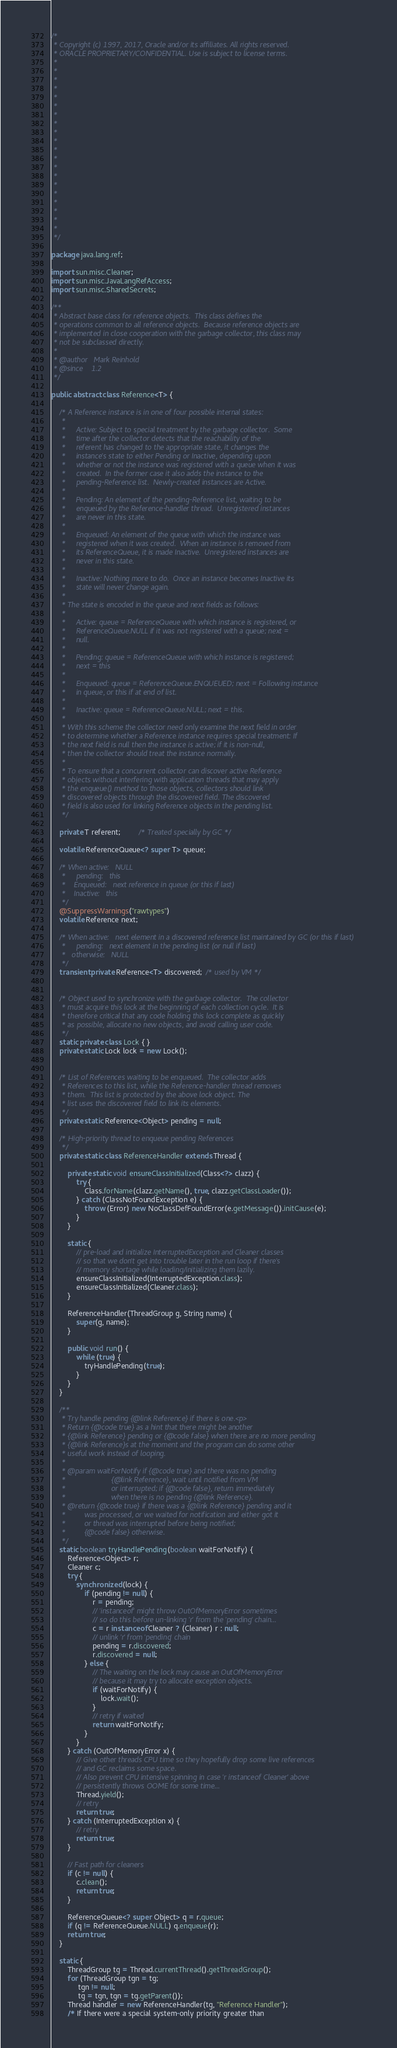Convert code to text. <code><loc_0><loc_0><loc_500><loc_500><_Java_>/*
 * Copyright (c) 1997, 2017, Oracle and/or its affiliates. All rights reserved.
 * ORACLE PROPRIETARY/CONFIDENTIAL. Use is subject to license terms.
 *
 *
 *
 *
 *
 *
 *
 *
 *
 *
 *
 *
 *
 *
 *
 *
 *
 *
 *
 *
 */

package java.lang.ref;

import sun.misc.Cleaner;
import sun.misc.JavaLangRefAccess;
import sun.misc.SharedSecrets;

/**
 * Abstract base class for reference objects.  This class defines the
 * operations common to all reference objects.  Because reference objects are
 * implemented in close cooperation with the garbage collector, this class may
 * not be subclassed directly.
 *
 * @author   Mark Reinhold
 * @since    1.2
 */

public abstract class Reference<T> {

    /* A Reference instance is in one of four possible internal states:
     *
     *     Active: Subject to special treatment by the garbage collector.  Some
     *     time after the collector detects that the reachability of the
     *     referent has changed to the appropriate state, it changes the
     *     instance's state to either Pending or Inactive, depending upon
     *     whether or not the instance was registered with a queue when it was
     *     created.  In the former case it also adds the instance to the
     *     pending-Reference list.  Newly-created instances are Active.
     *
     *     Pending: An element of the pending-Reference list, waiting to be
     *     enqueued by the Reference-handler thread.  Unregistered instances
     *     are never in this state.
     *
     *     Enqueued: An element of the queue with which the instance was
     *     registered when it was created.  When an instance is removed from
     *     its ReferenceQueue, it is made Inactive.  Unregistered instances are
     *     never in this state.
     *
     *     Inactive: Nothing more to do.  Once an instance becomes Inactive its
     *     state will never change again.
     *
     * The state is encoded in the queue and next fields as follows:
     *
     *     Active: queue = ReferenceQueue with which instance is registered, or
     *     ReferenceQueue.NULL if it was not registered with a queue; next =
     *     null.
     *
     *     Pending: queue = ReferenceQueue with which instance is registered;
     *     next = this
     *
     *     Enqueued: queue = ReferenceQueue.ENQUEUED; next = Following instance
     *     in queue, or this if at end of list.
     *
     *     Inactive: queue = ReferenceQueue.NULL; next = this.
     *
     * With this scheme the collector need only examine the next field in order
     * to determine whether a Reference instance requires special treatment: If
     * the next field is null then the instance is active; if it is non-null,
     * then the collector should treat the instance normally.
     *
     * To ensure that a concurrent collector can discover active Reference
     * objects without interfering with application threads that may apply
     * the enqueue() method to those objects, collectors should link
     * discovered objects through the discovered field. The discovered
     * field is also used for linking Reference objects in the pending list.
     */

    private T referent;         /* Treated specially by GC */

    volatile ReferenceQueue<? super T> queue;

    /* When active:   NULL
     *     pending:   this
     *    Enqueued:   next reference in queue (or this if last)
     *    Inactive:   this
     */
    @SuppressWarnings("rawtypes")
    volatile Reference next;

    /* When active:   next element in a discovered reference list maintained by GC (or this if last)
     *     pending:   next element in the pending list (or null if last)
     *   otherwise:   NULL
     */
    transient private Reference<T> discovered;  /* used by VM */


    /* Object used to synchronize with the garbage collector.  The collector
     * must acquire this lock at the beginning of each collection cycle.  It is
     * therefore critical that any code holding this lock complete as quickly
     * as possible, allocate no new objects, and avoid calling user code.
     */
    static private class Lock { }
    private static Lock lock = new Lock();


    /* List of References waiting to be enqueued.  The collector adds
     * References to this list, while the Reference-handler thread removes
     * them.  This list is protected by the above lock object. The
     * list uses the discovered field to link its elements.
     */
    private static Reference<Object> pending = null;

    /* High-priority thread to enqueue pending References
     */
    private static class ReferenceHandler extends Thread {

        private static void ensureClassInitialized(Class<?> clazz) {
            try {
                Class.forName(clazz.getName(), true, clazz.getClassLoader());
            } catch (ClassNotFoundException e) {
                throw (Error) new NoClassDefFoundError(e.getMessage()).initCause(e);
            }
        }

        static {
            // pre-load and initialize InterruptedException and Cleaner classes
            // so that we don't get into trouble later in the run loop if there's
            // memory shortage while loading/initializing them lazily.
            ensureClassInitialized(InterruptedException.class);
            ensureClassInitialized(Cleaner.class);
        }

        ReferenceHandler(ThreadGroup g, String name) {
            super(g, name);
        }

        public void run() {
            while (true) {
                tryHandlePending(true);
            }
        }
    }

    /**
     * Try handle pending {@link Reference} if there is one.<p>
     * Return {@code true} as a hint that there might be another
     * {@link Reference} pending or {@code false} when there are no more pending
     * {@link Reference}s at the moment and the program can do some other
     * useful work instead of looping.
     *
     * @param waitForNotify if {@code true} and there was no pending
     *                      {@link Reference}, wait until notified from VM
     *                      or interrupted; if {@code false}, return immediately
     *                      when there is no pending {@link Reference}.
     * @return {@code true} if there was a {@link Reference} pending and it
     *         was processed, or we waited for notification and either got it
     *         or thread was interrupted before being notified;
     *         {@code false} otherwise.
     */
    static boolean tryHandlePending(boolean waitForNotify) {
        Reference<Object> r;
        Cleaner c;
        try {
            synchronized (lock) {
                if (pending != null) {
                    r = pending;
                    // 'instanceof' might throw OutOfMemoryError sometimes
                    // so do this before un-linking 'r' from the 'pending' chain...
                    c = r instanceof Cleaner ? (Cleaner) r : null;
                    // unlink 'r' from 'pending' chain
                    pending = r.discovered;
                    r.discovered = null;
                } else {
                    // The waiting on the lock may cause an OutOfMemoryError
                    // because it may try to allocate exception objects.
                    if (waitForNotify) {
                        lock.wait();
                    }
                    // retry if waited
                    return waitForNotify;
                }
            }
        } catch (OutOfMemoryError x) {
            // Give other threads CPU time so they hopefully drop some live references
            // and GC reclaims some space.
            // Also prevent CPU intensive spinning in case 'r instanceof Cleaner' above
            // persistently throws OOME for some time...
            Thread.yield();
            // retry
            return true;
        } catch (InterruptedException x) {
            // retry
            return true;
        }

        // Fast path for cleaners
        if (c != null) {
            c.clean();
            return true;
        }

        ReferenceQueue<? super Object> q = r.queue;
        if (q != ReferenceQueue.NULL) q.enqueue(r);
        return true;
    }

    static {
        ThreadGroup tg = Thread.currentThread().getThreadGroup();
        for (ThreadGroup tgn = tg;
             tgn != null;
             tg = tgn, tgn = tg.getParent());
        Thread handler = new ReferenceHandler(tg, "Reference Handler");
        /* If there were a special system-only priority greater than</code> 